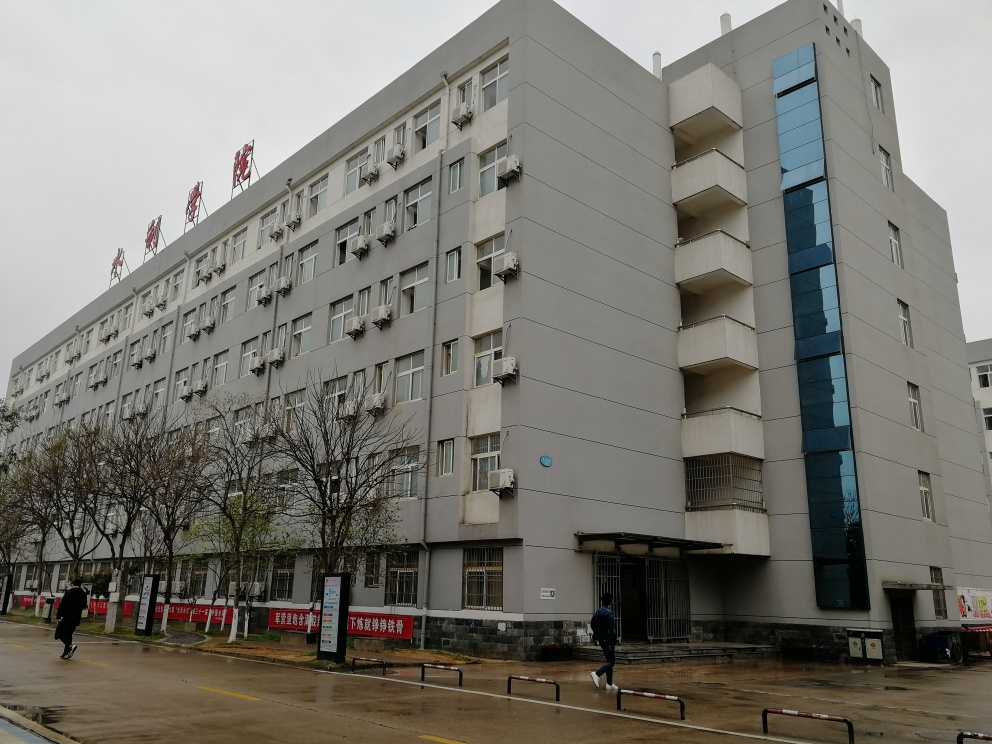Is the image pixelated?
 No 